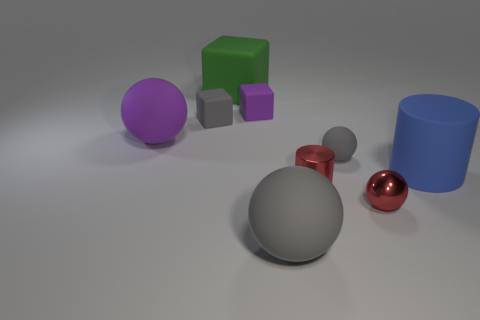Is the number of tiny gray rubber blocks to the left of the large block greater than the number of big green rubber things that are to the right of the blue matte thing? Yes, there are more tiny gray rubber blocks positioned to the left of the large gray sphere than the number of large green rubber cubes situated to the right of the blue matte cylinder. 